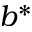Convert formula to latex. <formula><loc_0><loc_0><loc_500><loc_500>b ^ { * }</formula> 